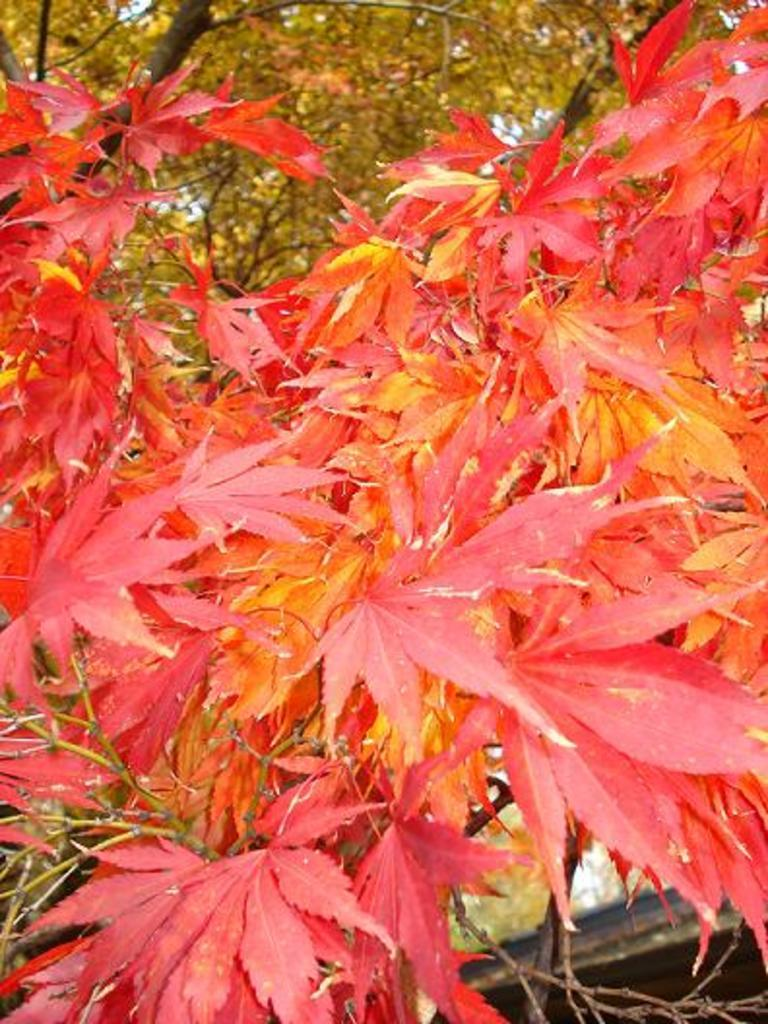What type of vegetation is visible in the image? There are leaves of a tree in the image. Can you describe the leaves in the image? The leaves appear to be green and are likely from a deciduous tree. What might be the purpose of the leaves in the image? The leaves are likely part of a tree that provides shade, oxygen, and habitat for various organisms. What type of knife is being used to commit a crime in the image? There is no knife or crime present in the image; it only features leaves of a tree. 